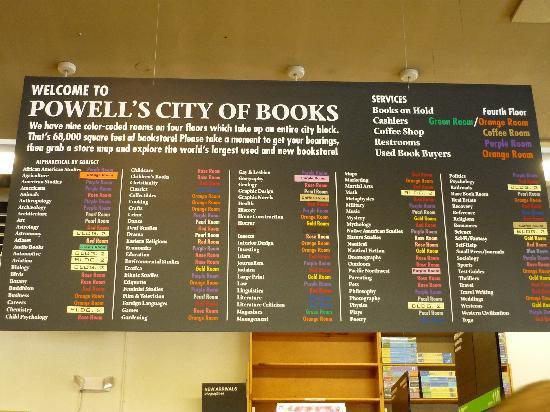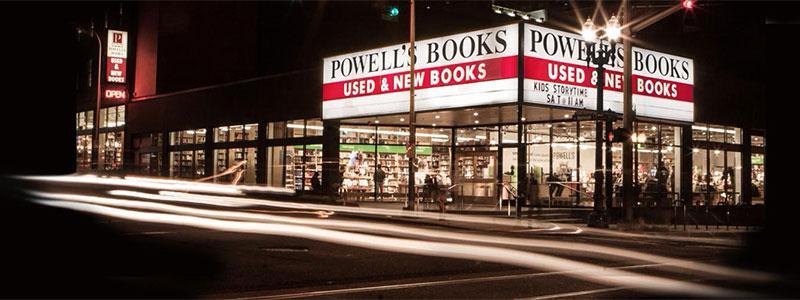The first image is the image on the left, the second image is the image on the right. Evaluate the accuracy of this statement regarding the images: "There is a single woman with black hair who has sat down to read near at least one other shelf of books.". Is it true? Answer yes or no. No. The first image is the image on the left, the second image is the image on the right. Examine the images to the left and right. Is the description "A person is sitting down." accurate? Answer yes or no. No. 